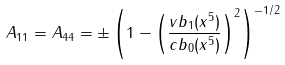Convert formula to latex. <formula><loc_0><loc_0><loc_500><loc_500>A _ { 1 1 } = A _ { 4 4 } = \pm \left ( 1 - \left ( \frac { v b _ { 1 } ( x ^ { 5 } ) } { c b _ { 0 } ( x ^ { 5 } ) } \right ) ^ { 2 } \right ) ^ { - 1 / 2 } \quad</formula> 